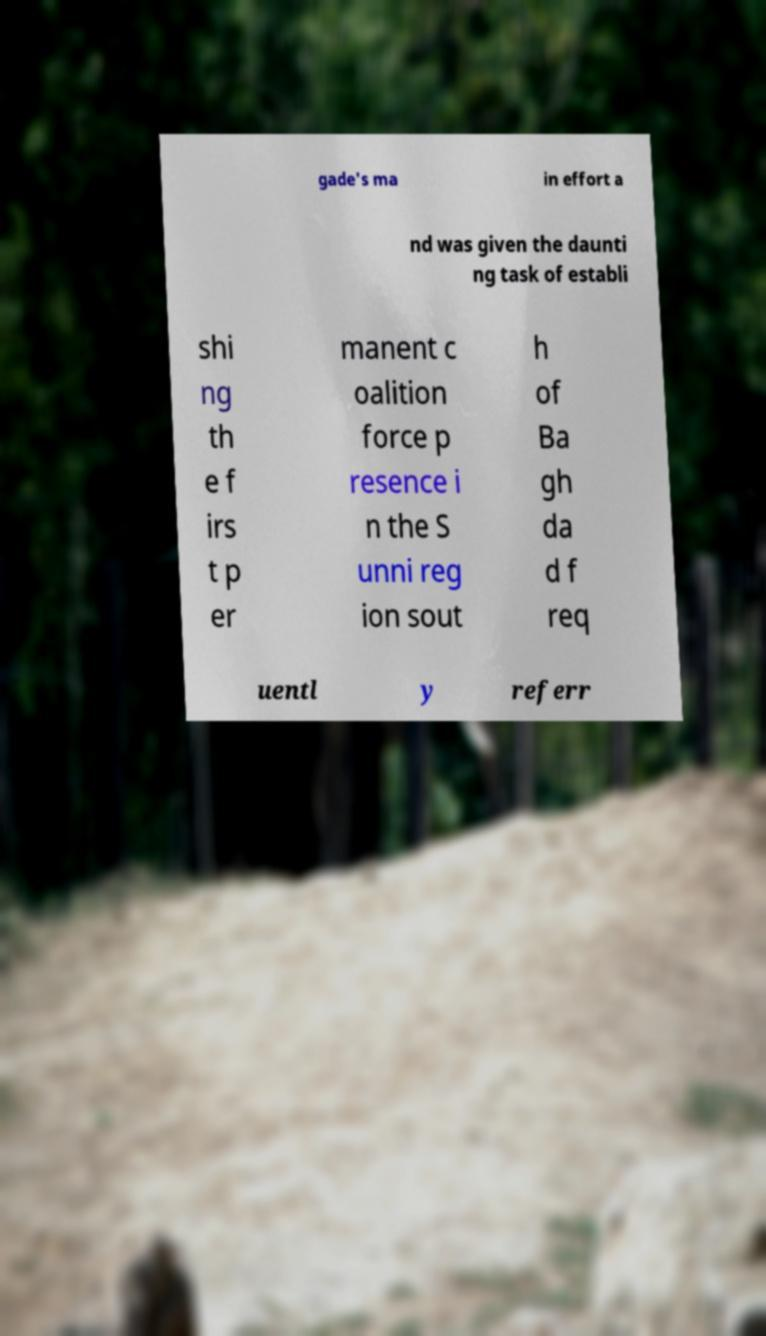Can you read and provide the text displayed in the image?This photo seems to have some interesting text. Can you extract and type it out for me? gade's ma in effort a nd was given the daunti ng task of establi shi ng th e f irs t p er manent c oalition force p resence i n the S unni reg ion sout h of Ba gh da d f req uentl y referr 